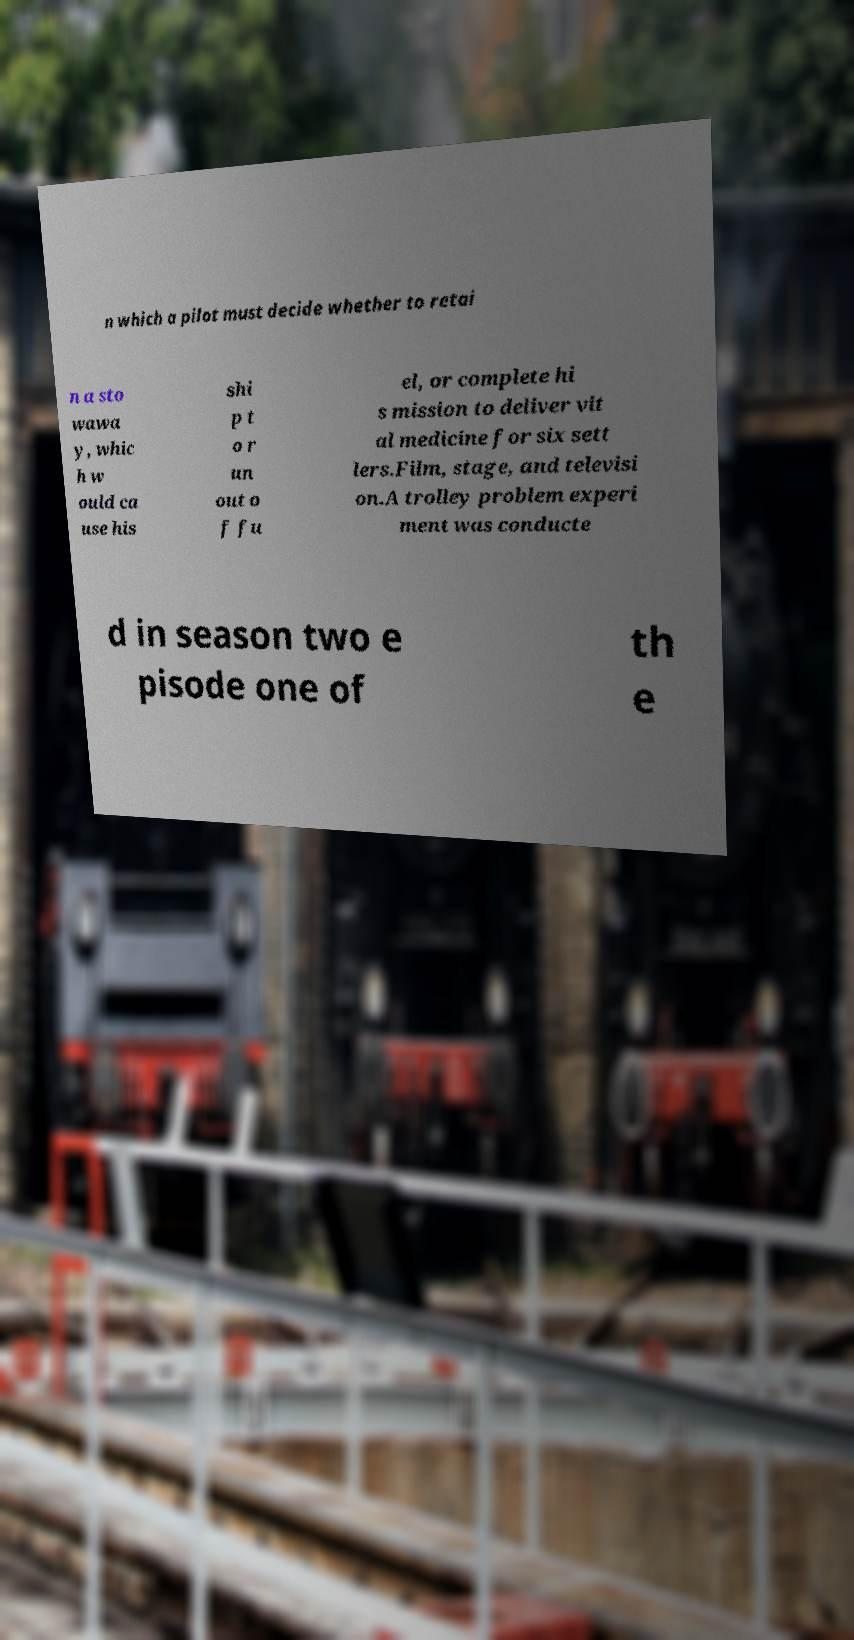Please identify and transcribe the text found in this image. n which a pilot must decide whether to retai n a sto wawa y, whic h w ould ca use his shi p t o r un out o f fu el, or complete hi s mission to deliver vit al medicine for six sett lers.Film, stage, and televisi on.A trolley problem experi ment was conducte d in season two e pisode one of th e 